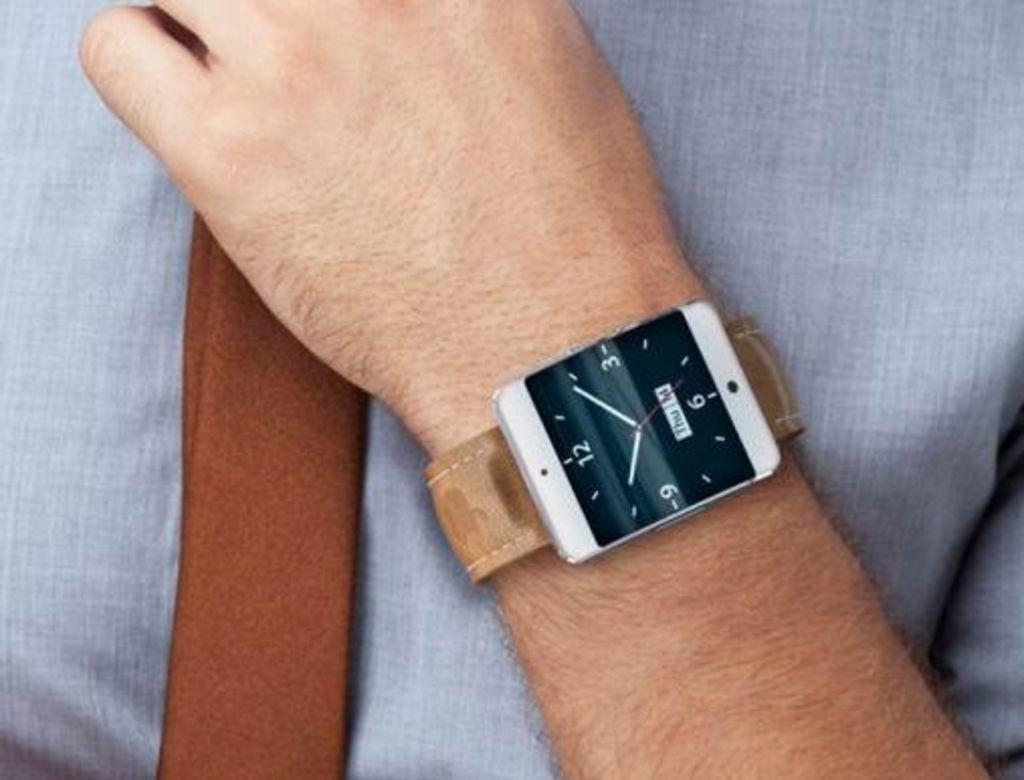<image>
Relay a brief, clear account of the picture shown. A wrist watch with a brown band shows the time as 10:09 